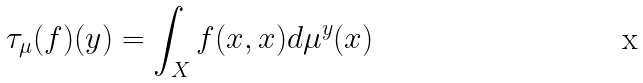<formula> <loc_0><loc_0><loc_500><loc_500>\tau _ { \mu } ( f ) ( y ) = \int _ { X } f ( x , x ) d \mu ^ { y } ( x )</formula> 